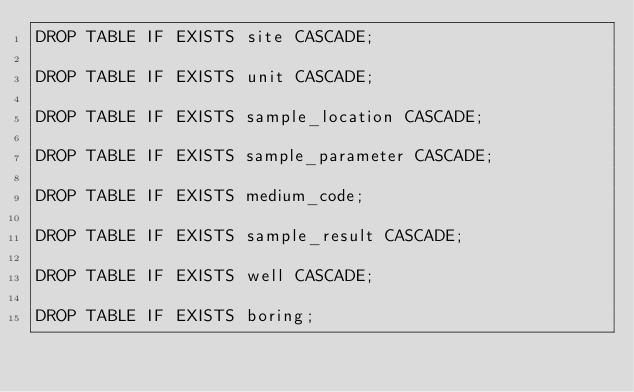Convert code to text. <code><loc_0><loc_0><loc_500><loc_500><_SQL_>DROP TABLE IF EXISTS site CASCADE;

DROP TABLE IF EXISTS unit CASCADE;
 
DROP TABLE IF EXISTS sample_location CASCADE;

DROP TABLE IF EXISTS sample_parameter CASCADE;

DROP TABLE IF EXISTS medium_code;

DROP TABLE IF EXISTS sample_result CASCADE;

DROP TABLE IF EXISTS well CASCADE;

DROP TABLE IF EXISTS boring;
</code> 